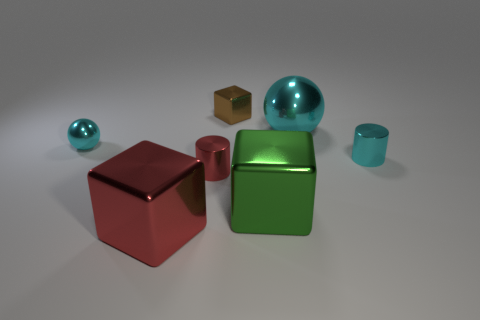Add 1 small rubber cylinders. How many objects exist? 8 Subtract all blocks. How many objects are left? 4 Subtract all big gray spheres. Subtract all large metal blocks. How many objects are left? 5 Add 7 green metal things. How many green metal things are left? 8 Add 2 big balls. How many big balls exist? 3 Subtract 1 cyan balls. How many objects are left? 6 